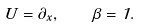<formula> <loc_0><loc_0><loc_500><loc_500>U = \partial _ { x } , \quad \beta = 1 .</formula> 